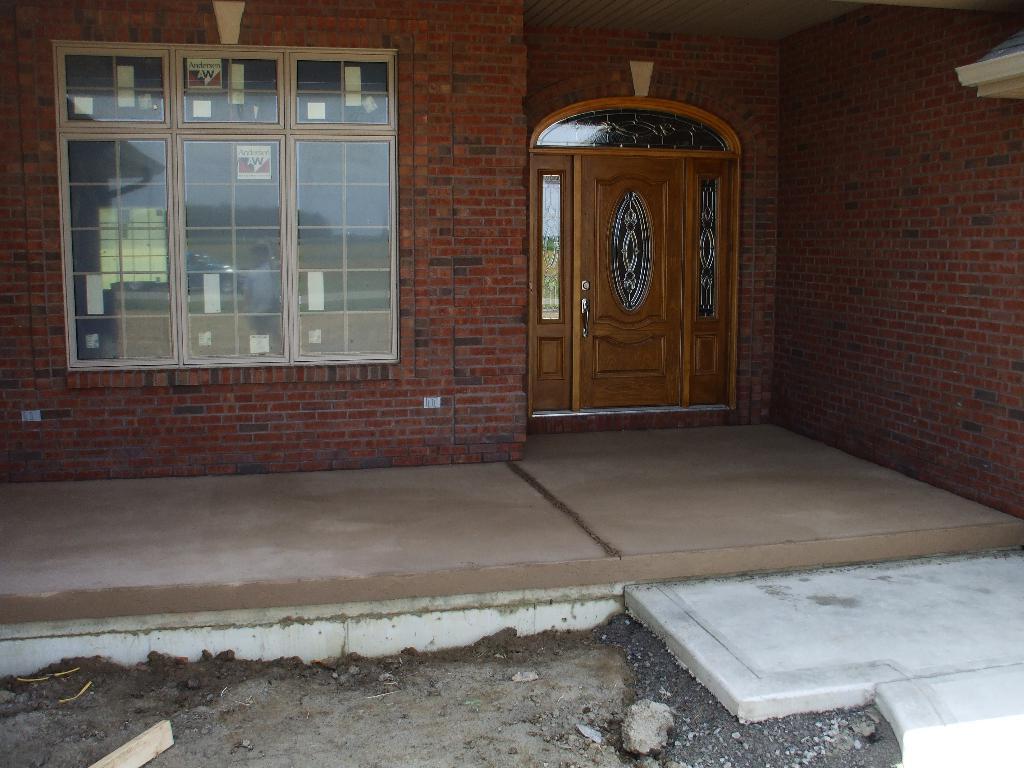Could you give a brief overview of what you see in this image? At the bottom of this image, there are stones, a wooden piece and sticks on the ground. On the right side, there is a tile floor. In the background, there is a building having glass windows, a wooden door and the brick walls. 